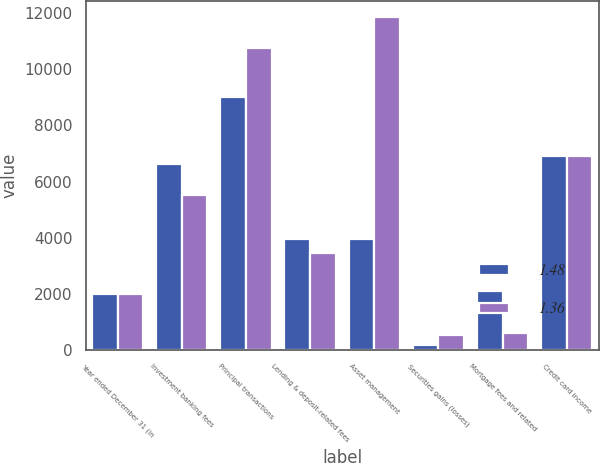Convert chart. <chart><loc_0><loc_0><loc_500><loc_500><stacked_bar_chart><ecel><fcel>Year ended December 31 (in<fcel>Investment banking fees<fcel>Principal transactions<fcel>Lending & deposit-related fees<fcel>Asset management<fcel>Securities gains (losses)<fcel>Mortgage fees and related<fcel>Credit card income<nl><fcel>1.48<fcel>2007<fcel>6635<fcel>9015<fcel>3938<fcel>3938<fcel>164<fcel>2118<fcel>6911<nl><fcel>1.36<fcel>2006<fcel>5520<fcel>10778<fcel>3468<fcel>11855<fcel>543<fcel>591<fcel>6913<nl></chart> 